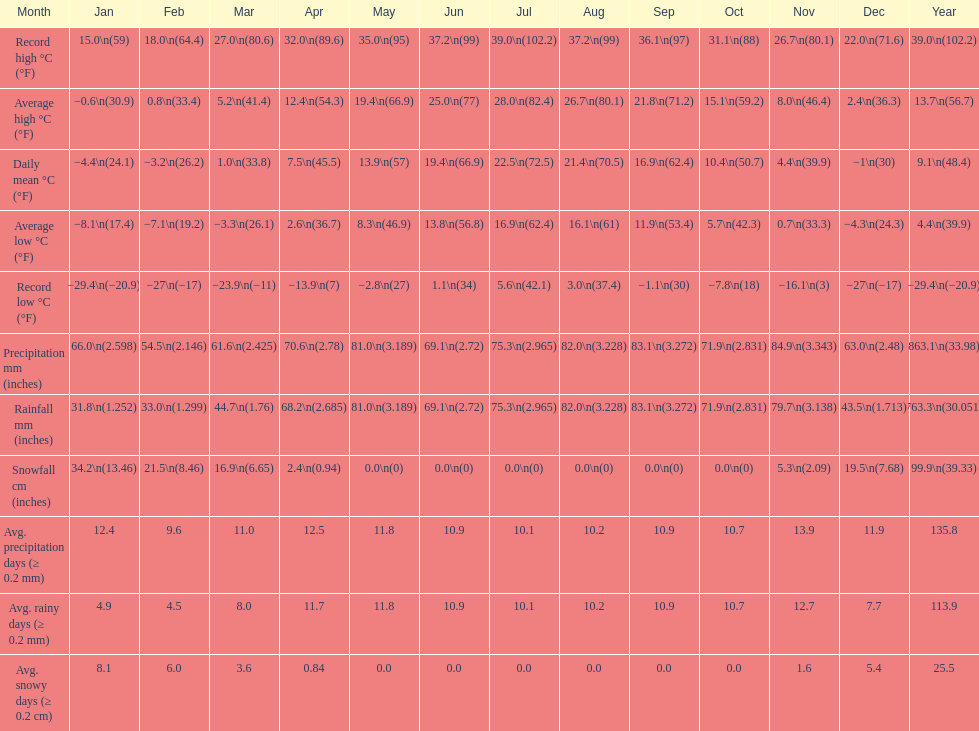Which month experienced a 2 September. 